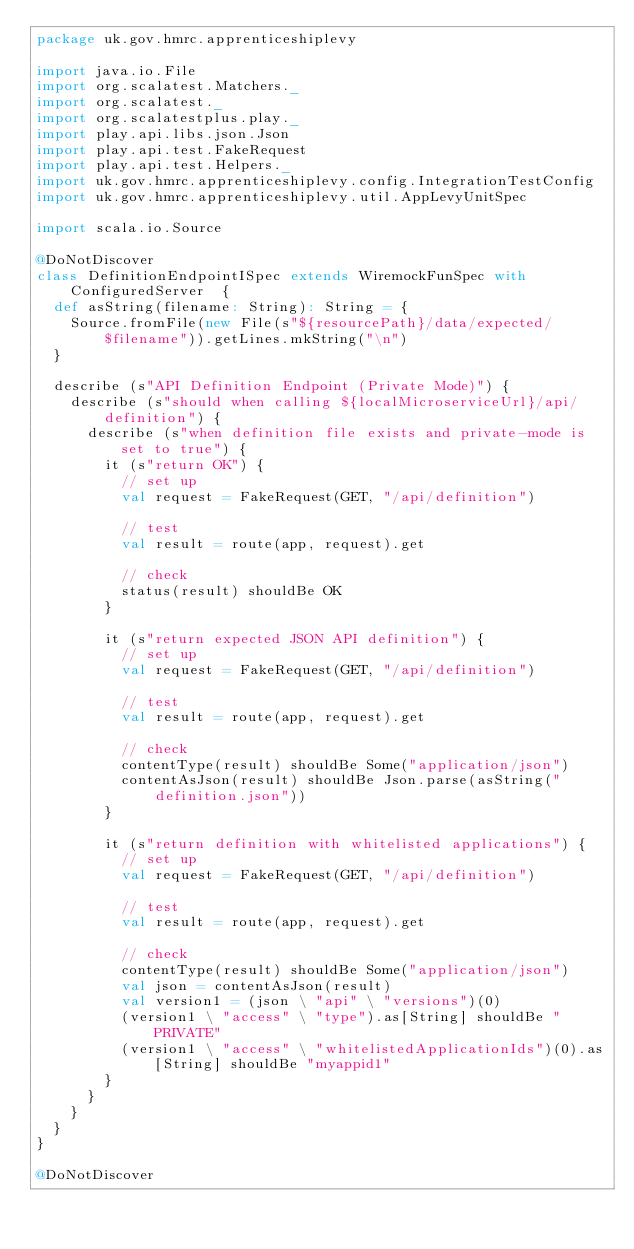<code> <loc_0><loc_0><loc_500><loc_500><_Scala_>package uk.gov.hmrc.apprenticeshiplevy

import java.io.File
import org.scalatest.Matchers._
import org.scalatest._
import org.scalatestplus.play._
import play.api.libs.json.Json
import play.api.test.FakeRequest
import play.api.test.Helpers._
import uk.gov.hmrc.apprenticeshiplevy.config.IntegrationTestConfig
import uk.gov.hmrc.apprenticeshiplevy.util.AppLevyUnitSpec

import scala.io.Source

@DoNotDiscover
class DefinitionEndpointISpec extends WiremockFunSpec with ConfiguredServer  {
  def asString(filename: String): String = {
    Source.fromFile(new File(s"${resourcePath}/data/expected/$filename")).getLines.mkString("\n")
  }

  describe (s"API Definition Endpoint (Private Mode)") {
    describe (s"should when calling ${localMicroserviceUrl}/api/definition") {
      describe (s"when definition file exists and private-mode is set to true") {
        it (s"return OK") {
          // set up
          val request = FakeRequest(GET, "/api/definition")

          // test
          val result = route(app, request).get

          // check
          status(result) shouldBe OK
        }

        it (s"return expected JSON API definition") {
          // set up
          val request = FakeRequest(GET, "/api/definition")

          // test
          val result = route(app, request).get

          // check
          contentType(result) shouldBe Some("application/json")
          contentAsJson(result) shouldBe Json.parse(asString("definition.json"))
        }

        it (s"return definition with whitelisted applications") {
          // set up
          val request = FakeRequest(GET, "/api/definition")

          // test
          val result = route(app, request).get

          // check
          contentType(result) shouldBe Some("application/json")
          val json = contentAsJson(result)
          val version1 = (json \ "api" \ "versions")(0)
          (version1 \ "access" \ "type").as[String] shouldBe "PRIVATE"
          (version1 \ "access" \ "whitelistedApplicationIds")(0).as[String] shouldBe "myappid1"
        }
      }
    }
  }
}

@DoNotDiscover</code> 